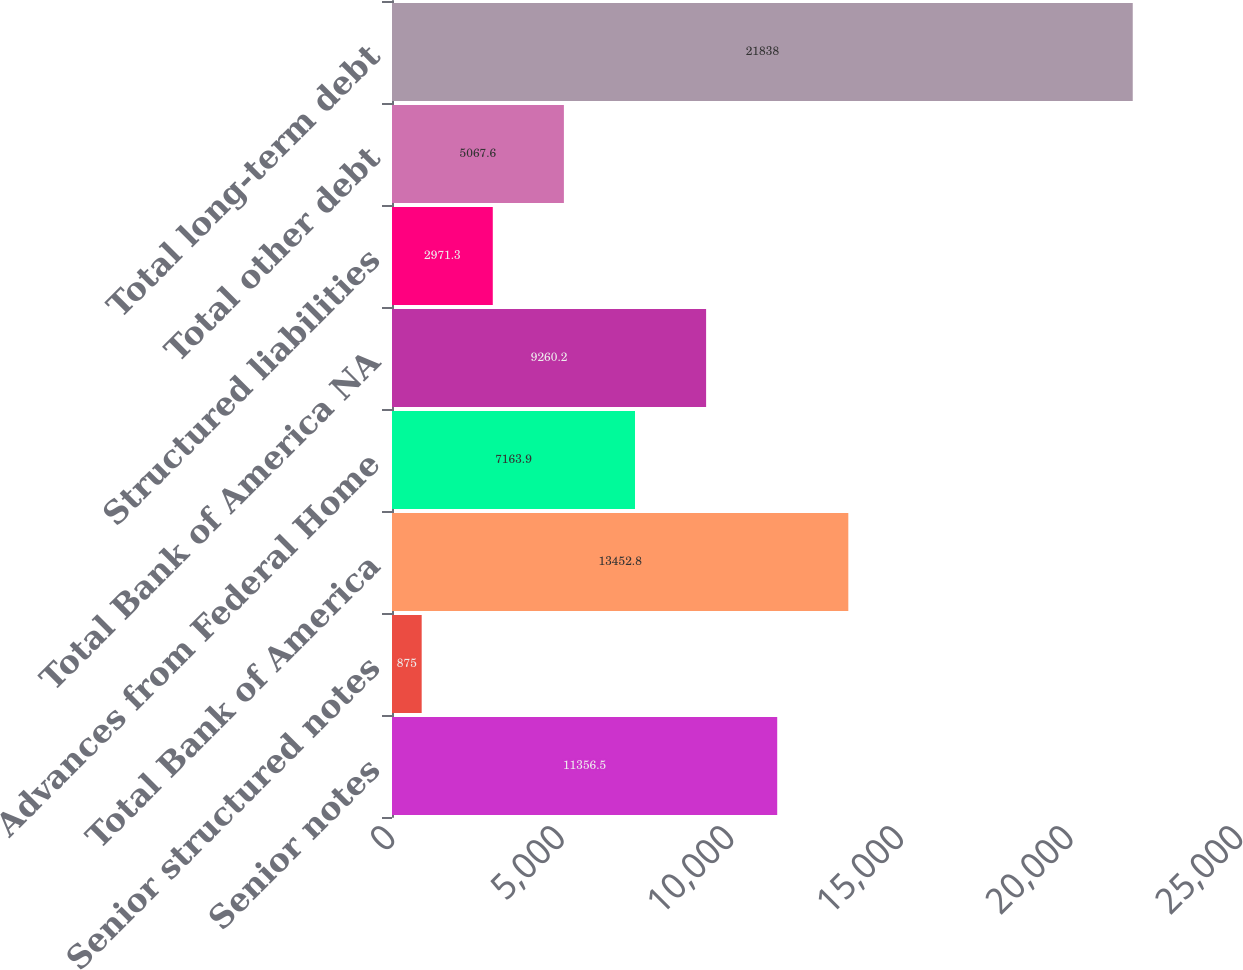Convert chart to OTSL. <chart><loc_0><loc_0><loc_500><loc_500><bar_chart><fcel>Senior notes<fcel>Senior structured notes<fcel>Total Bank of America<fcel>Advances from Federal Home<fcel>Total Bank of America NA<fcel>Structured liabilities<fcel>Total other debt<fcel>Total long-term debt<nl><fcel>11356.5<fcel>875<fcel>13452.8<fcel>7163.9<fcel>9260.2<fcel>2971.3<fcel>5067.6<fcel>21838<nl></chart> 